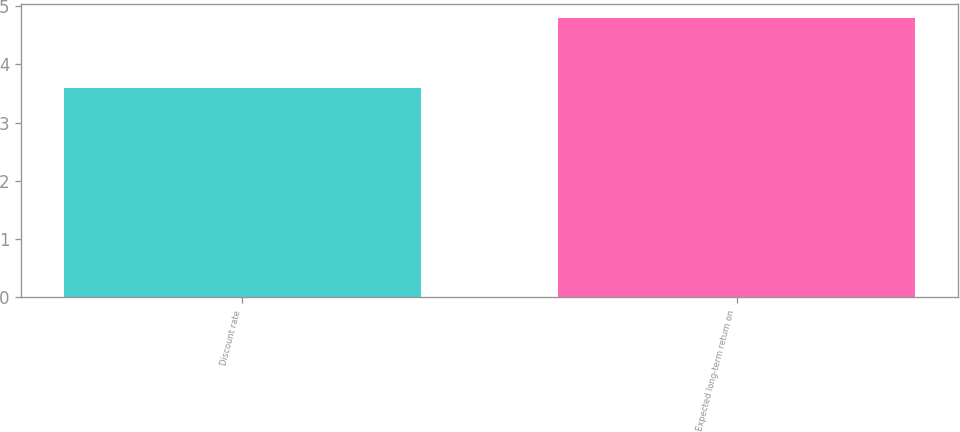<chart> <loc_0><loc_0><loc_500><loc_500><bar_chart><fcel>Discount rate<fcel>Expected long-term return on<nl><fcel>3.6<fcel>4.8<nl></chart> 